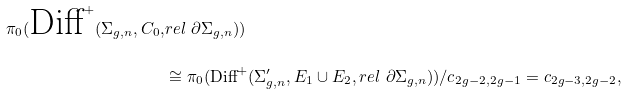<formula> <loc_0><loc_0><loc_500><loc_500>\pi _ { 0 } ( \text {Diff} ^ { + } ( \Sigma _ { g , n } , C _ { 0 } , & r e l \ \partial \Sigma _ { g , n } ) ) \\ & \cong \pi _ { 0 } ( \text {Diff} ^ { + } ( \Sigma _ { g , n } ^ { \prime } , E _ { 1 } \cup E _ { 2 } , r e l \ \partial \Sigma _ { g , n } ) ) / c _ { 2 g - 2 , 2 g - 1 } = c _ { 2 g - 3 , 2 g - 2 } ,</formula> 